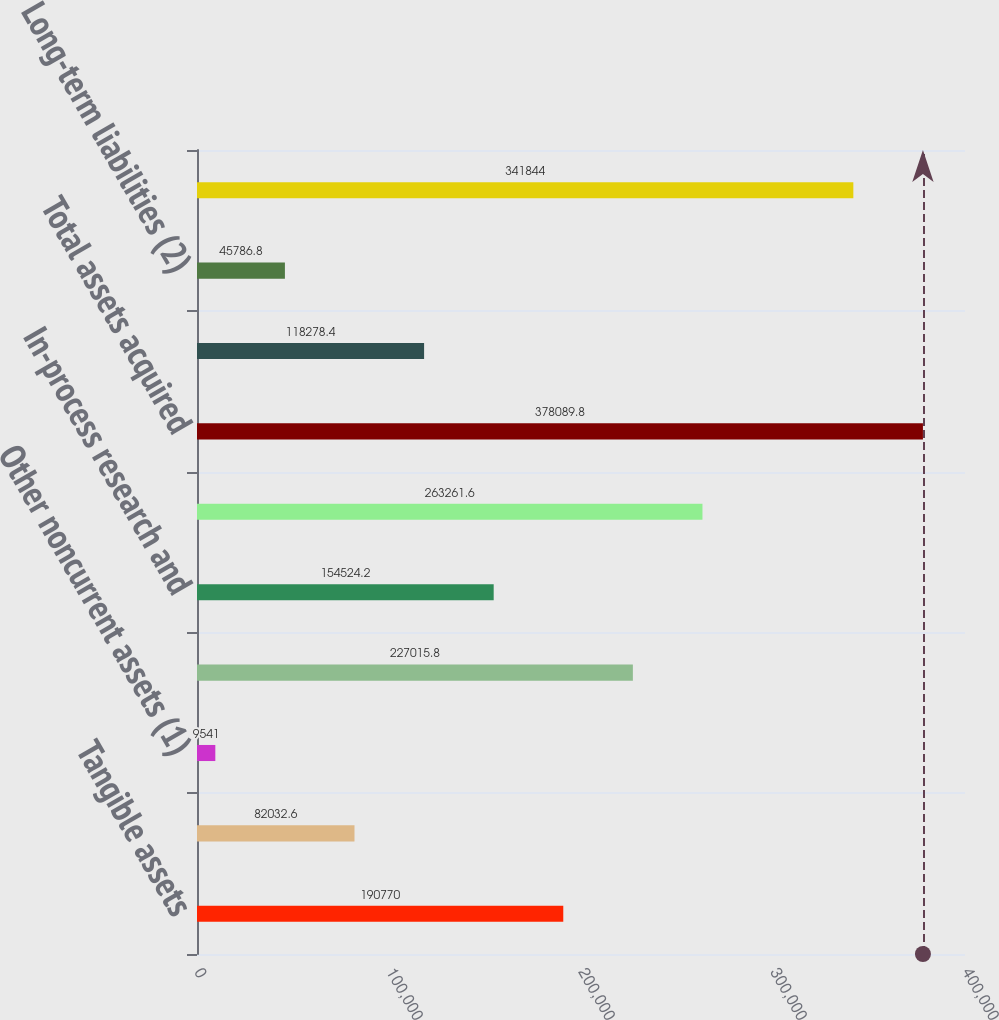<chart> <loc_0><loc_0><loc_500><loc_500><bar_chart><fcel>Tangible assets<fcel>Prepaid compensation costs<fcel>Other noncurrent assets (1)<fcel>Acquisition intangibles<fcel>In-process research and<fcel>Goodwill<fcel>Total assets acquired<fcel>Current liabilities<fcel>Long-term liabilities (2)<fcel>Net assets acquired<nl><fcel>190770<fcel>82032.6<fcel>9541<fcel>227016<fcel>154524<fcel>263262<fcel>378090<fcel>118278<fcel>45786.8<fcel>341844<nl></chart> 